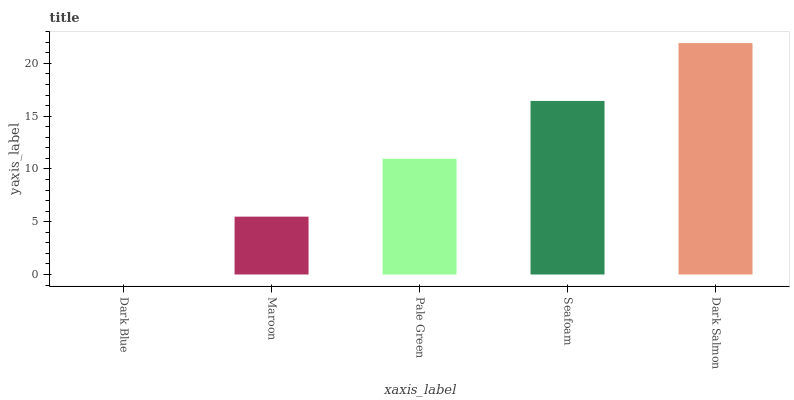Is Dark Blue the minimum?
Answer yes or no. Yes. Is Dark Salmon the maximum?
Answer yes or no. Yes. Is Maroon the minimum?
Answer yes or no. No. Is Maroon the maximum?
Answer yes or no. No. Is Maroon greater than Dark Blue?
Answer yes or no. Yes. Is Dark Blue less than Maroon?
Answer yes or no. Yes. Is Dark Blue greater than Maroon?
Answer yes or no. No. Is Maroon less than Dark Blue?
Answer yes or no. No. Is Pale Green the high median?
Answer yes or no. Yes. Is Pale Green the low median?
Answer yes or no. Yes. Is Maroon the high median?
Answer yes or no. No. Is Maroon the low median?
Answer yes or no. No. 